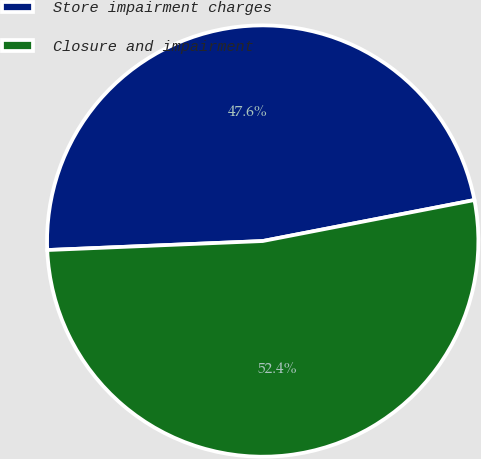Convert chart to OTSL. <chart><loc_0><loc_0><loc_500><loc_500><pie_chart><fcel>Store impairment charges<fcel>Closure and impairment<nl><fcel>47.62%<fcel>52.38%<nl></chart> 